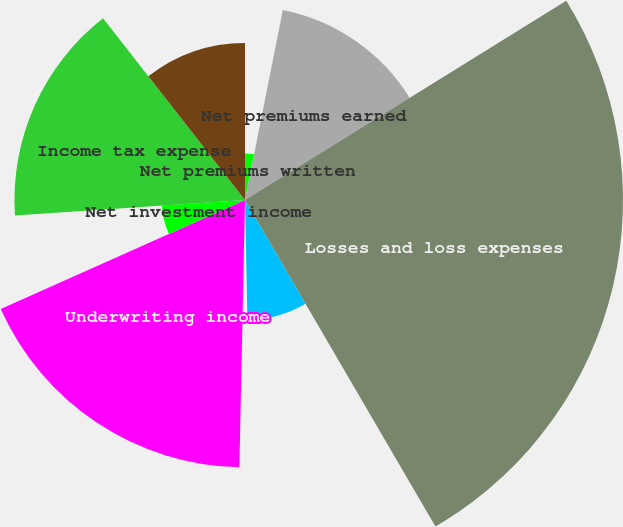Convert chart to OTSL. <chart><loc_0><loc_0><loc_500><loc_500><pie_chart><fcel>Net premiums written<fcel>Net premiums earned<fcel>Losses and loss expenses<fcel>Policy acquisition costs<fcel>Administrative expenses<fcel>Underwriting income<fcel>Net investment income<fcel>Income tax expense<fcel>Net income<nl><fcel>3.13%<fcel>13.04%<fcel>25.43%<fcel>8.08%<fcel>0.66%<fcel>17.99%<fcel>5.61%<fcel>15.51%<fcel>10.56%<nl></chart> 